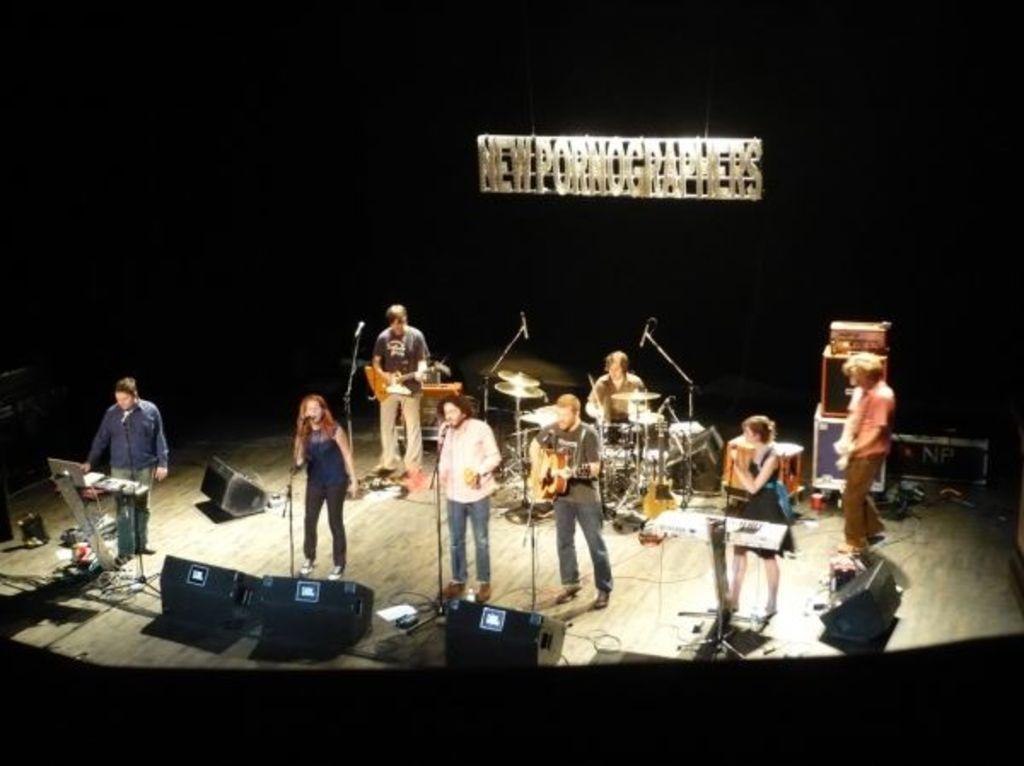Can you describe this image briefly? There are a group of people performing on a musical stage. There is a woman standing on the left side and she is singing. There is a person on the right side and he is holding a guitar in his hand. In the background there is a man sitting and he is playing a drum with drumsticks. 